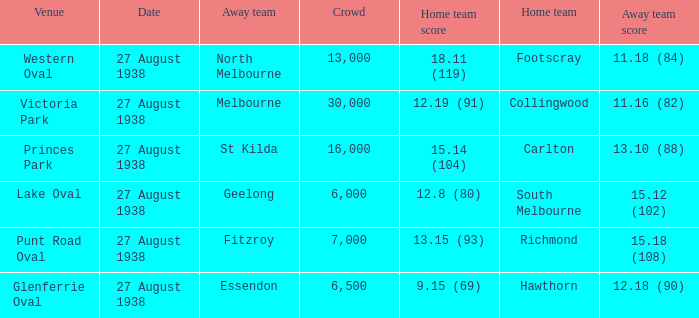Which Team plays at Western Oval? Footscray. 